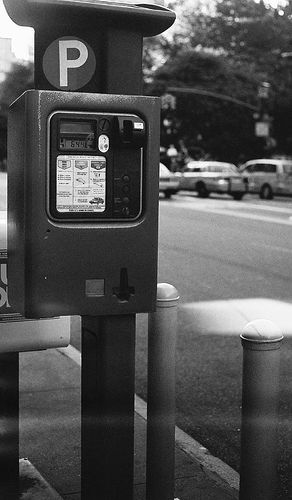Describe the objects in this image and their specific colors. I can see parking meter in white, black, gray, darkgray, and lightgray tones, car in white, gray, black, darkgray, and lightgray tones, car in white, gray, black, darkgray, and lightgray tones, and car in white, black, gray, darkgray, and lightgray tones in this image. 